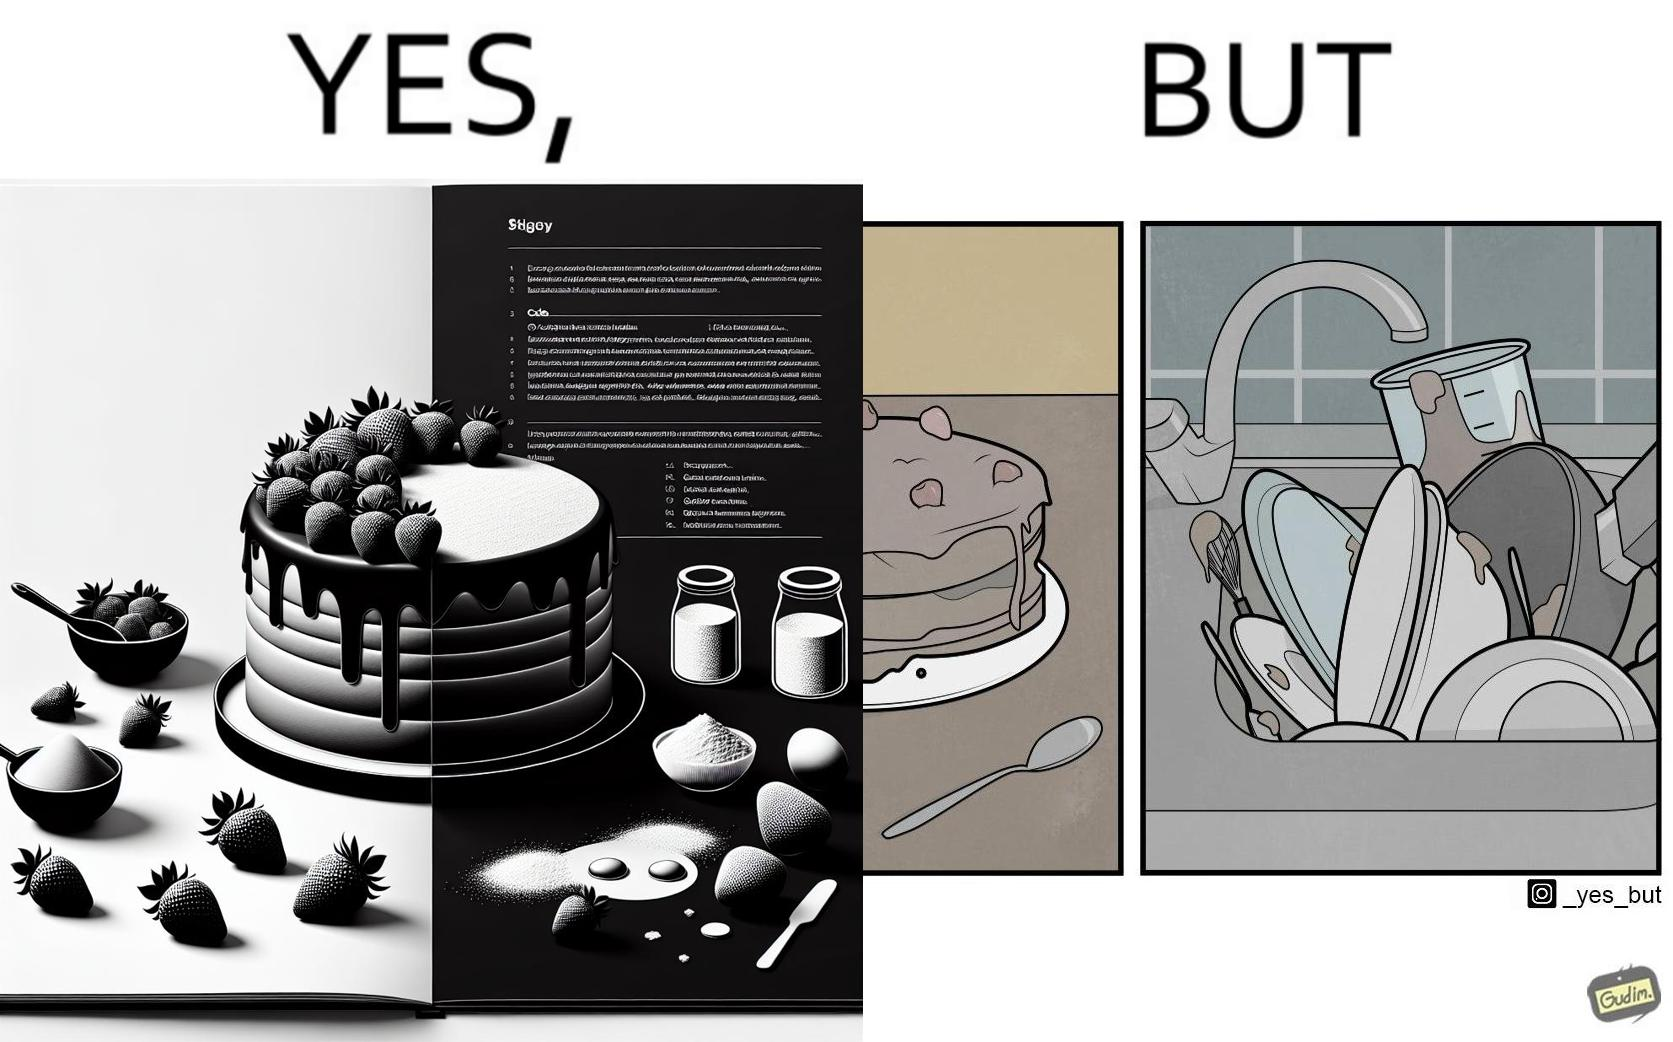Provide a description of this image. The image is funny, as when making a strawberry cake using  a recipe book, the outcome is not quite what is expected, and one has to wash the used utensils afterwards as well. 